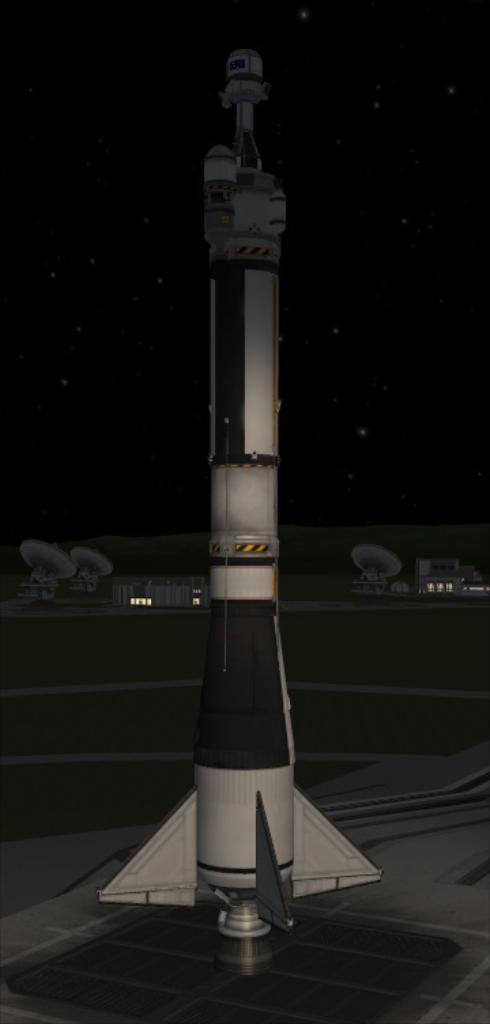What is the main subject of the digital art in the image? The main subject of the digital art in the image is a rocket. What colors are used to depict the rocket? The rocket is white and black in color. What can be seen in the background of the image? There are antennas and buildings in the background of the image. What is the color of the sky in the background of the image? The sky is dark in the background of the image. How does the parcel get delivered to the rocket in the image? There is no parcel present in the image, so it cannot be delivered to the rocket. What type of wrench is used to fix the rocket in the image? There is no wrench present in the image, and the rocket does not appear to be in need of repair. 